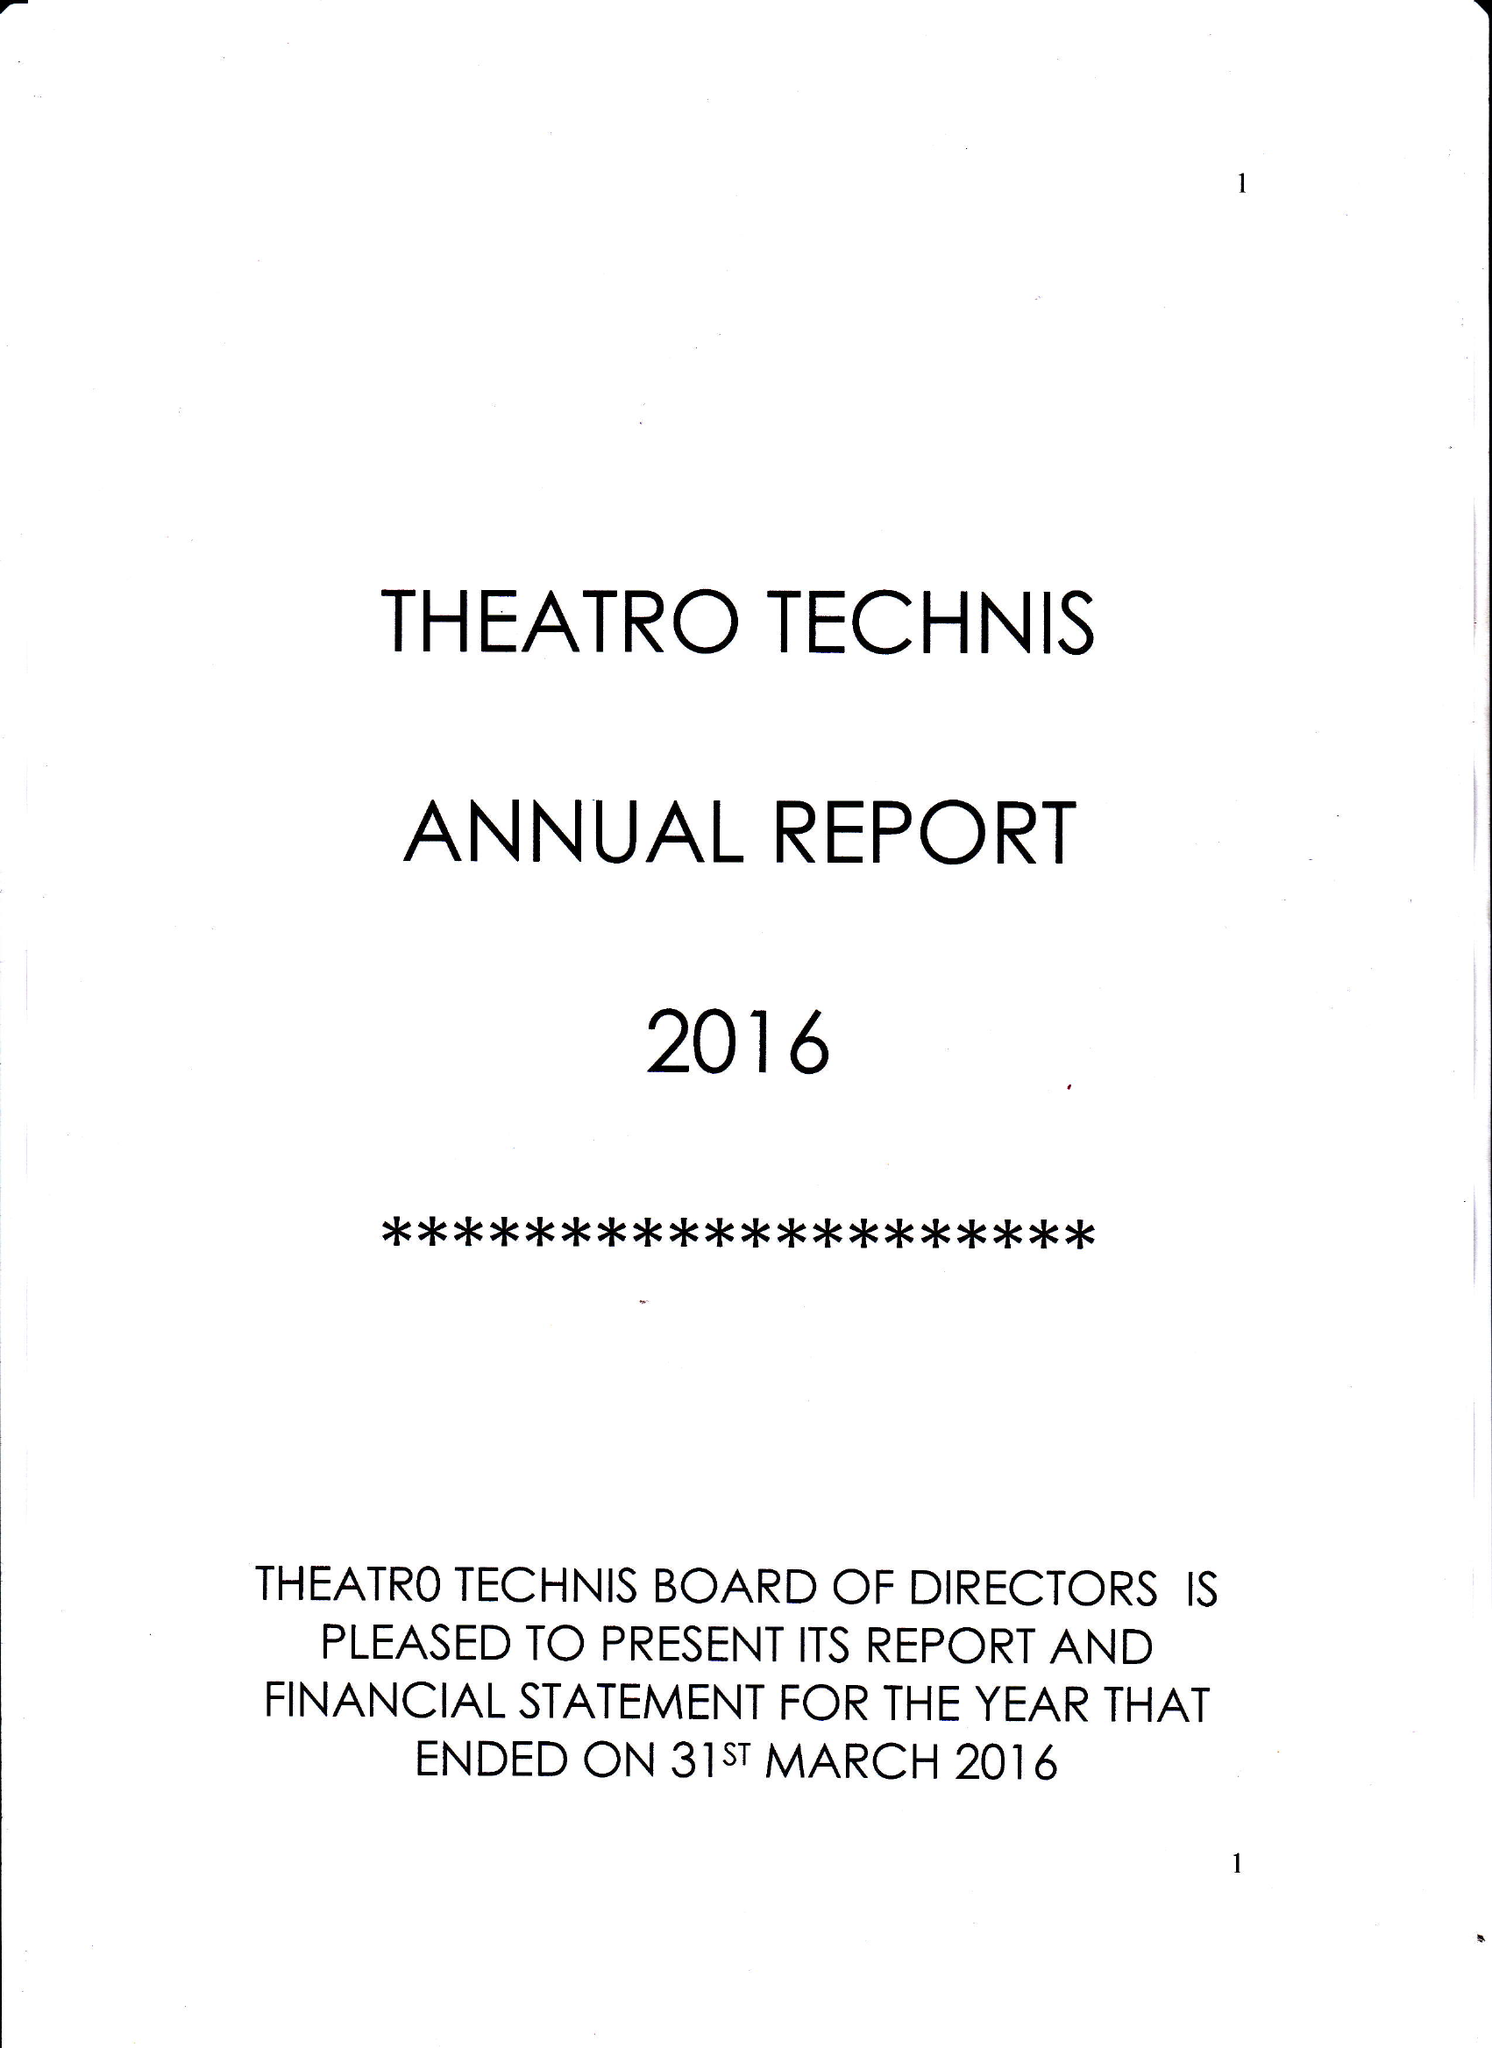What is the value for the address__post_town?
Answer the question using a single word or phrase. LONDON 